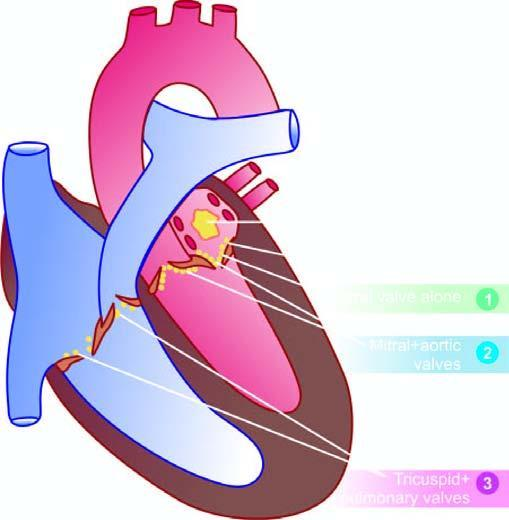what are denoted for the frequency of valvular involvement?
Answer the question using a single word or phrase. Serial numbers 1 